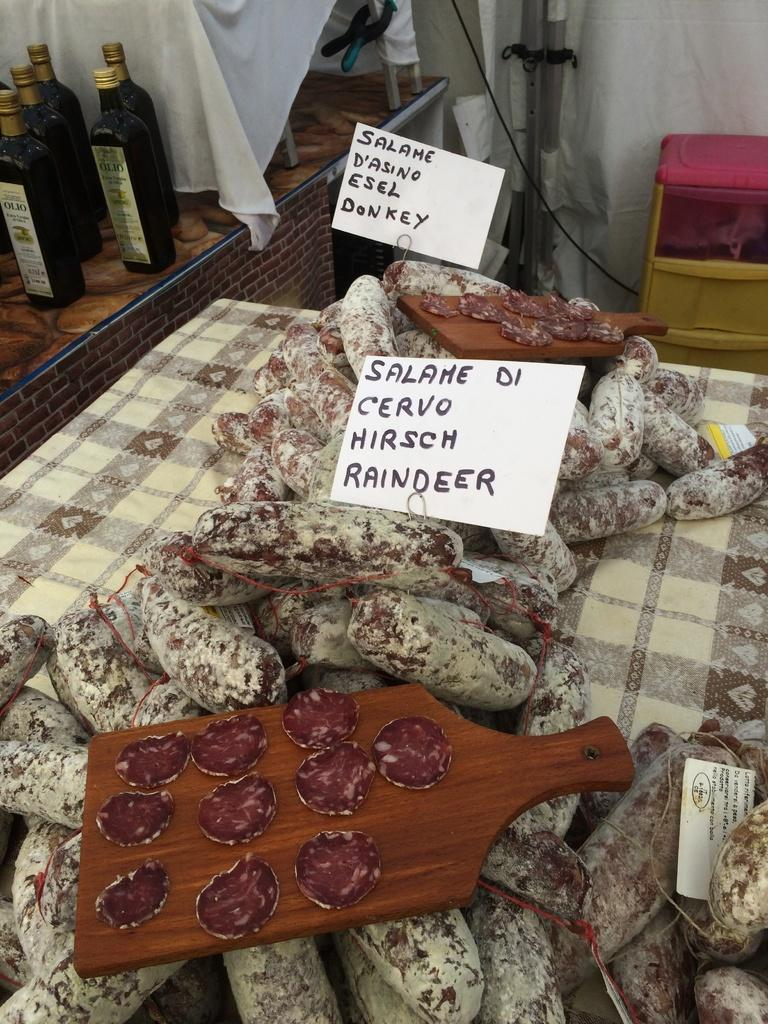<image>
Give a short and clear explanation of the subsequent image. Several links of donkey and reindeer salami are stacked on a table. 